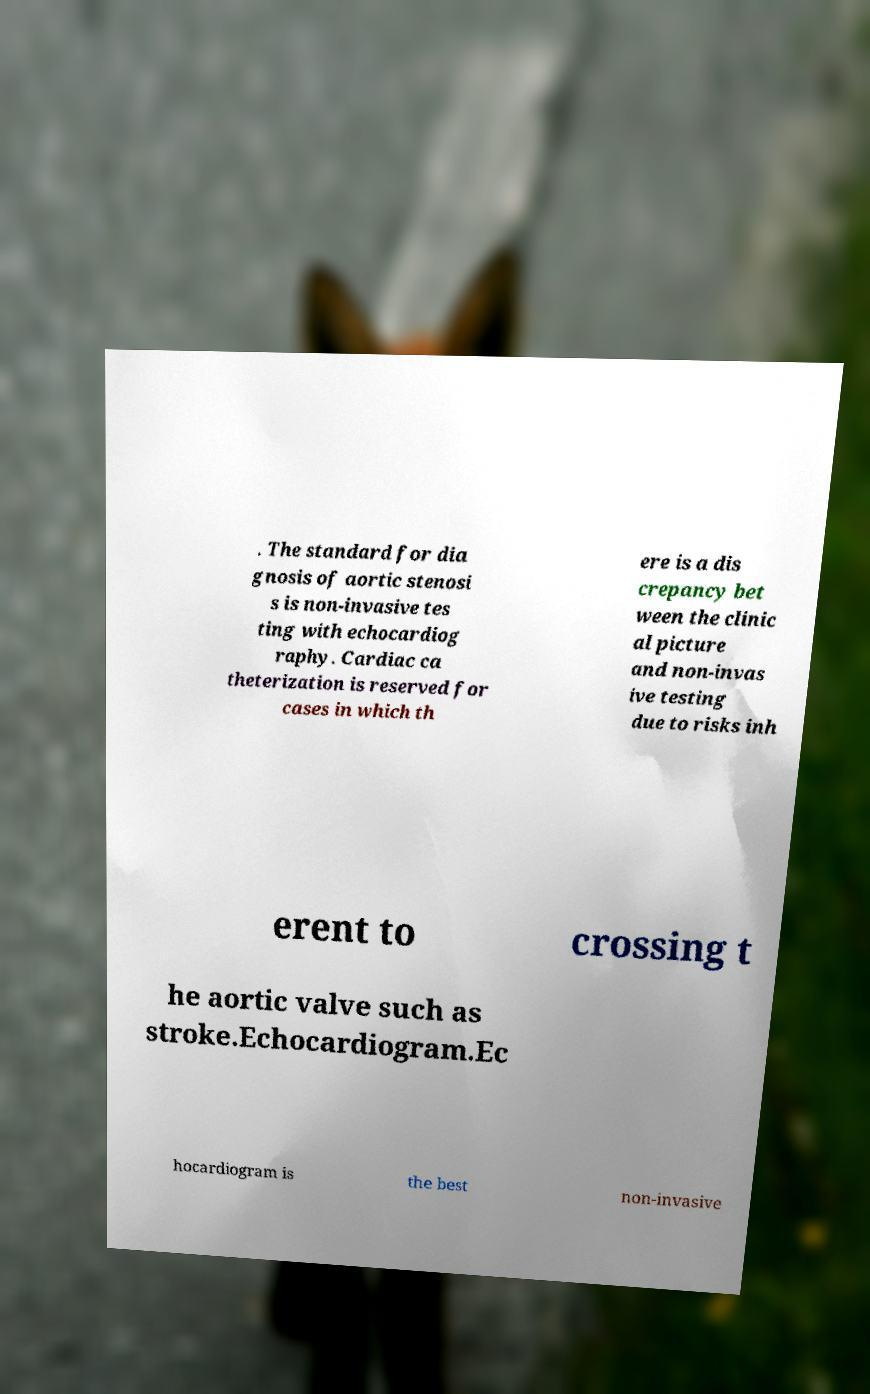Could you extract and type out the text from this image? . The standard for dia gnosis of aortic stenosi s is non-invasive tes ting with echocardiog raphy. Cardiac ca theterization is reserved for cases in which th ere is a dis crepancy bet ween the clinic al picture and non-invas ive testing due to risks inh erent to crossing t he aortic valve such as stroke.Echocardiogram.Ec hocardiogram is the best non-invasive 